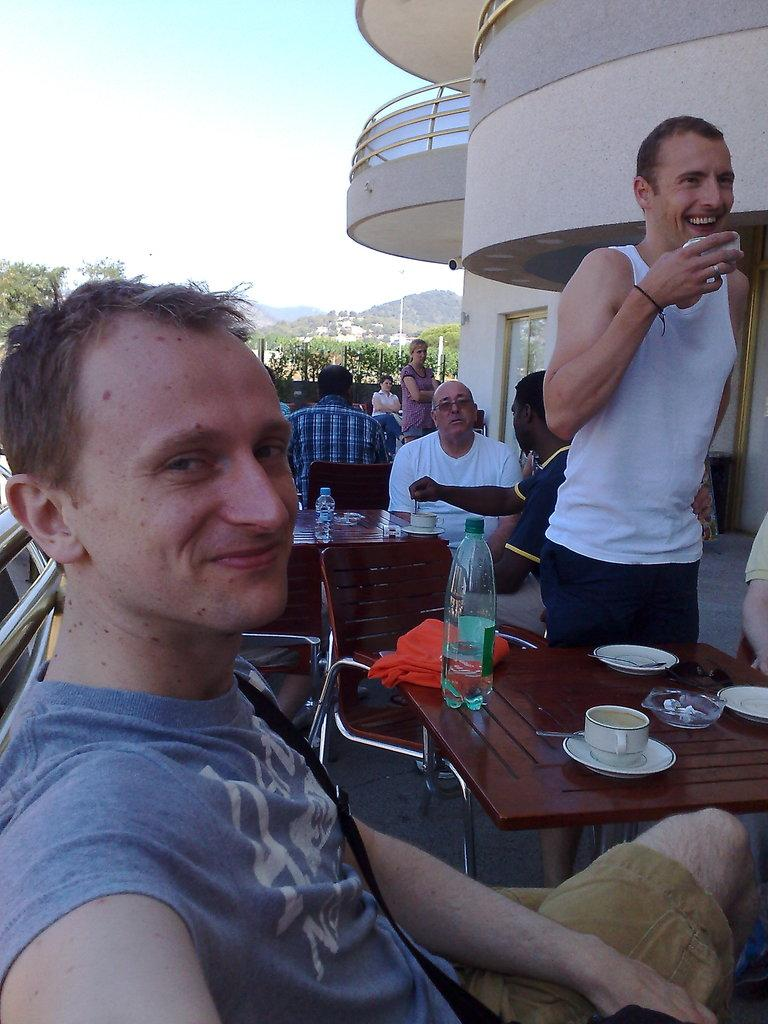How many people are in the image? There are persons in the image, but the exact number is not specified. What type of furniture is present in the image? There are tables, chairs, and other items like bottles, cups, saucers, and bowls in the image. What can be seen in the background of the image? There is a building, trees, and the sky visible in the background of the image. What type of competition is taking place in the image? There is no competition present in the image. Can you describe the bears that are sitting on the chairs in the image? There are no bears present in the image; it features only persons and various objects. 